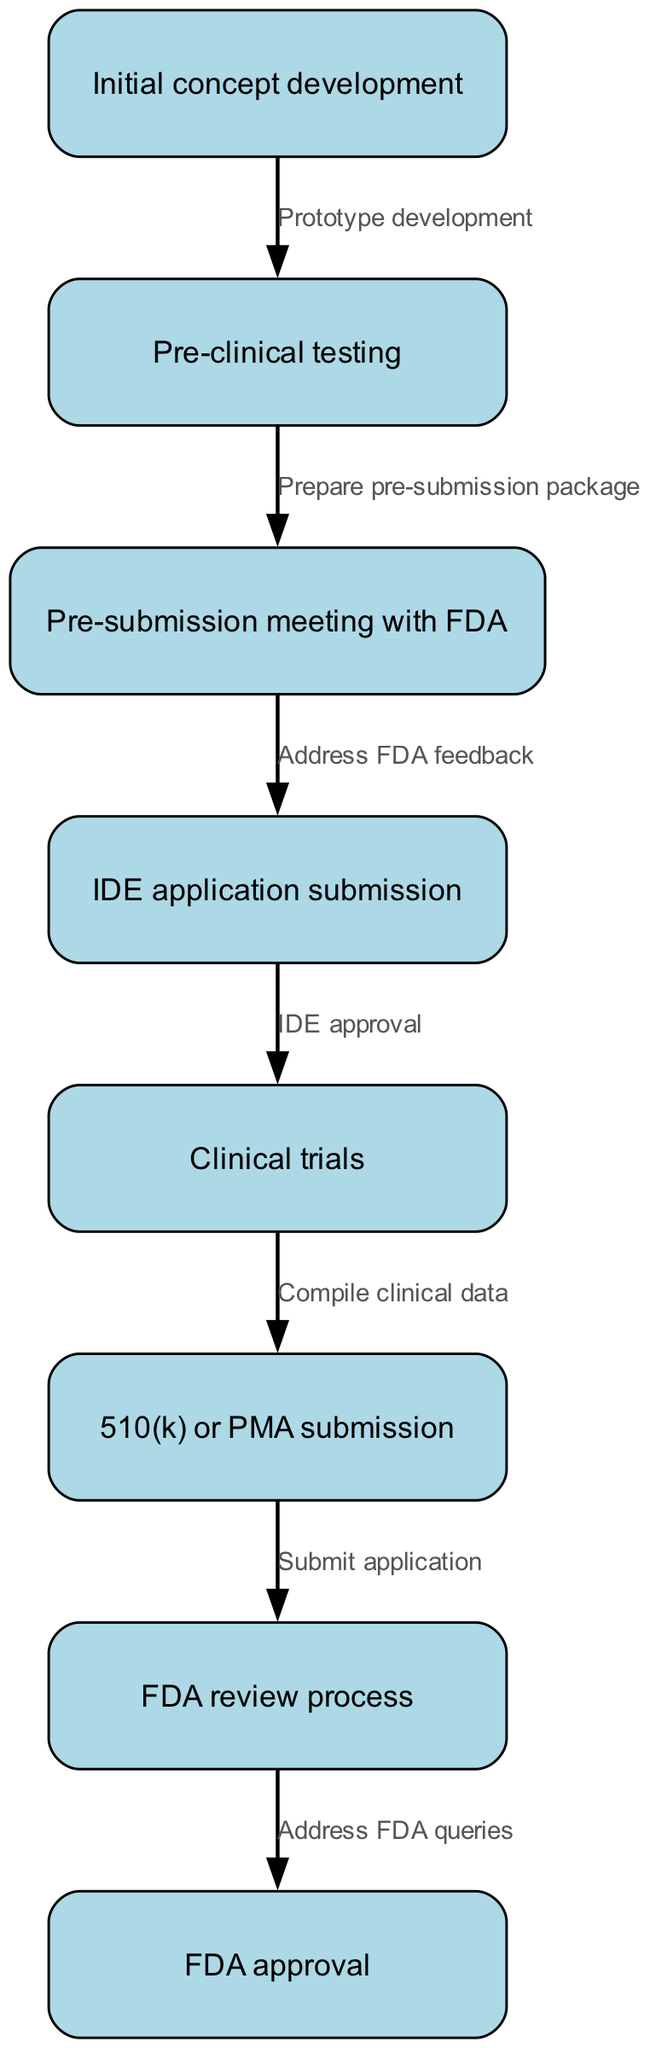What is the first step in the FDA approval workflow? The first step is represented as the very first node in the diagram labeled "Initial concept development."
Answer: Initial concept development How many nodes are in the diagram? To find the number of nodes, we can count the individual steps represented in the "nodes" section of the data, which lists eight steps in total.
Answer: 8 What follows pre-clinical testing in the workflow? In the flow of the diagram, the node directly following "Pre-clinical testing" is "Pre-submission meeting with FDA," which shows the next step in the process.
Answer: Pre-submission meeting with FDA What is the final step after FDA review process? The last node connected after "FDA review process" indicates the last step in the diagram, which is labeled as "FDA approval."
Answer: FDA approval Which step is related to submitting the IDE application? The node that follows "Pre-submission meeting with FDA" is connected by the edge labeled "Address FDA feedback," leading to "IDE application submission," which is specifically about submitting the IDE application.
Answer: IDE application submission What step comes before clinical trials? By examining the flow of the diagram, "IDE application submission" directly precedes "Clinical trials," indicating the order of steps.
Answer: IDE application submission How many edges are in the diagram? To determine the number of edges, we count the connections made between nodes in the "edges" section of the data, which includes a total of seven connections.
Answer: 7 What is the relationship between clinical trials and the submission type? The arrow showing the flow indicates that "Clinical trials" leads to the compilation of clinical data, which directly relates to the preparation before the submission type of either 510(k) or PMA.
Answer: Compile clinical data What happens after submission of the application? The diagram progresses to show the next step after submission of the application leading to "FDA review process," indicating the sequence of events in the approval workflow.
Answer: FDA review process 